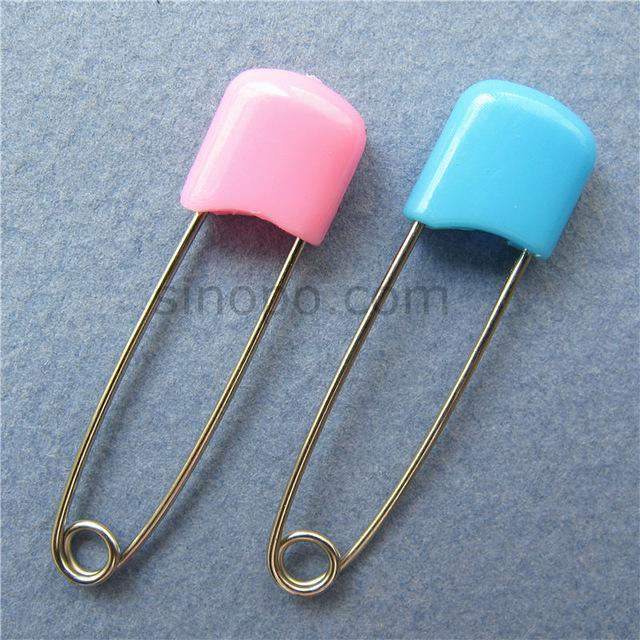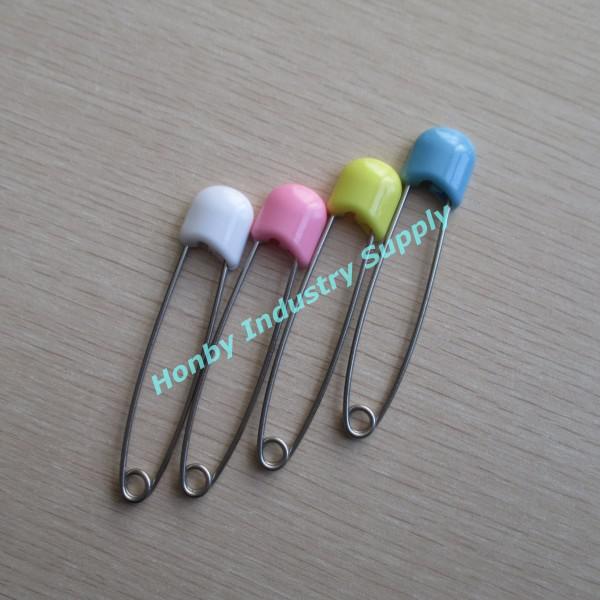The first image is the image on the left, the second image is the image on the right. Evaluate the accuracy of this statement regarding the images: "One image shows only two safety pins, one pink and one blue.". Is it true? Answer yes or no. Yes. 